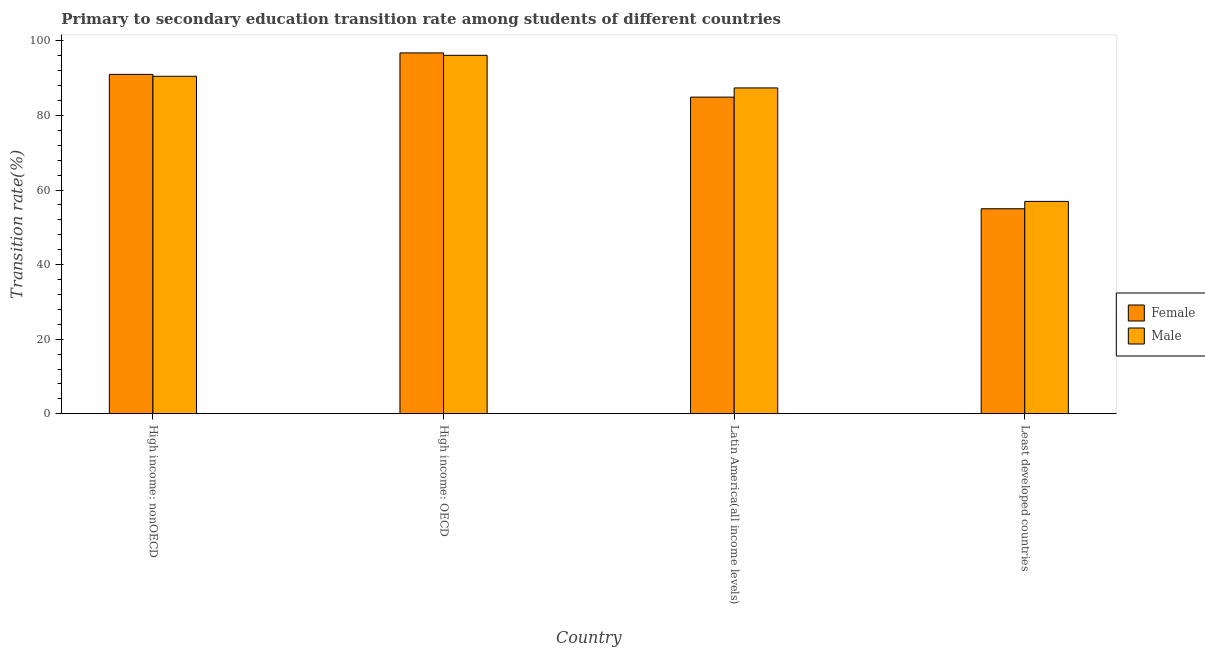Are the number of bars per tick equal to the number of legend labels?
Your answer should be compact. Yes. What is the label of the 2nd group of bars from the left?
Make the answer very short. High income: OECD. What is the transition rate among male students in Least developed countries?
Your response must be concise. 56.97. Across all countries, what is the maximum transition rate among male students?
Your answer should be very brief. 96.15. Across all countries, what is the minimum transition rate among female students?
Give a very brief answer. 54.99. In which country was the transition rate among male students maximum?
Your answer should be very brief. High income: OECD. In which country was the transition rate among male students minimum?
Keep it short and to the point. Least developed countries. What is the total transition rate among male students in the graph?
Provide a short and direct response. 331.06. What is the difference between the transition rate among female students in High income: nonOECD and that in Least developed countries?
Keep it short and to the point. 36.05. What is the difference between the transition rate among female students in Latin America(all income levels) and the transition rate among male students in High income: nonOECD?
Ensure brevity in your answer.  -5.59. What is the average transition rate among female students per country?
Give a very brief answer. 81.94. What is the difference between the transition rate among male students and transition rate among female students in Least developed countries?
Your response must be concise. 1.97. What is the ratio of the transition rate among female students in Latin America(all income levels) to that in Least developed countries?
Your answer should be very brief. 1.54. Is the transition rate among female students in High income: nonOECD less than that in Latin America(all income levels)?
Ensure brevity in your answer.  No. Is the difference between the transition rate among female students in High income: OECD and Least developed countries greater than the difference between the transition rate among male students in High income: OECD and Least developed countries?
Offer a terse response. Yes. What is the difference between the highest and the second highest transition rate among female students?
Ensure brevity in your answer.  5.75. What is the difference between the highest and the lowest transition rate among male students?
Keep it short and to the point. 39.19. How many bars are there?
Keep it short and to the point. 8. What is the difference between two consecutive major ticks on the Y-axis?
Provide a succinct answer. 20. Does the graph contain any zero values?
Make the answer very short. No. Does the graph contain grids?
Give a very brief answer. No. Where does the legend appear in the graph?
Provide a short and direct response. Center right. How many legend labels are there?
Provide a short and direct response. 2. What is the title of the graph?
Offer a terse response. Primary to secondary education transition rate among students of different countries. What is the label or title of the Y-axis?
Your response must be concise. Transition rate(%). What is the Transition rate(%) in Female in High income: nonOECD?
Make the answer very short. 91.05. What is the Transition rate(%) in Male in High income: nonOECD?
Your answer should be very brief. 90.53. What is the Transition rate(%) of Female in High income: OECD?
Offer a terse response. 96.8. What is the Transition rate(%) of Male in High income: OECD?
Your response must be concise. 96.15. What is the Transition rate(%) of Female in Latin America(all income levels)?
Offer a terse response. 84.94. What is the Transition rate(%) of Male in Latin America(all income levels)?
Your answer should be compact. 87.41. What is the Transition rate(%) in Female in Least developed countries?
Your answer should be compact. 54.99. What is the Transition rate(%) of Male in Least developed countries?
Offer a very short reply. 56.97. Across all countries, what is the maximum Transition rate(%) in Female?
Provide a short and direct response. 96.8. Across all countries, what is the maximum Transition rate(%) in Male?
Your response must be concise. 96.15. Across all countries, what is the minimum Transition rate(%) of Female?
Give a very brief answer. 54.99. Across all countries, what is the minimum Transition rate(%) in Male?
Ensure brevity in your answer.  56.97. What is the total Transition rate(%) in Female in the graph?
Ensure brevity in your answer.  327.78. What is the total Transition rate(%) in Male in the graph?
Give a very brief answer. 331.06. What is the difference between the Transition rate(%) of Female in High income: nonOECD and that in High income: OECD?
Your response must be concise. -5.75. What is the difference between the Transition rate(%) in Male in High income: nonOECD and that in High income: OECD?
Ensure brevity in your answer.  -5.62. What is the difference between the Transition rate(%) of Female in High income: nonOECD and that in Latin America(all income levels)?
Your response must be concise. 6.1. What is the difference between the Transition rate(%) in Male in High income: nonOECD and that in Latin America(all income levels)?
Keep it short and to the point. 3.12. What is the difference between the Transition rate(%) of Female in High income: nonOECD and that in Least developed countries?
Your answer should be compact. 36.05. What is the difference between the Transition rate(%) in Male in High income: nonOECD and that in Least developed countries?
Provide a short and direct response. 33.56. What is the difference between the Transition rate(%) of Female in High income: OECD and that in Latin America(all income levels)?
Give a very brief answer. 11.86. What is the difference between the Transition rate(%) in Male in High income: OECD and that in Latin America(all income levels)?
Give a very brief answer. 8.75. What is the difference between the Transition rate(%) in Female in High income: OECD and that in Least developed countries?
Your response must be concise. 41.81. What is the difference between the Transition rate(%) of Male in High income: OECD and that in Least developed countries?
Your answer should be compact. 39.19. What is the difference between the Transition rate(%) of Female in Latin America(all income levels) and that in Least developed countries?
Offer a very short reply. 29.95. What is the difference between the Transition rate(%) of Male in Latin America(all income levels) and that in Least developed countries?
Provide a short and direct response. 30.44. What is the difference between the Transition rate(%) in Female in High income: nonOECD and the Transition rate(%) in Male in High income: OECD?
Keep it short and to the point. -5.11. What is the difference between the Transition rate(%) in Female in High income: nonOECD and the Transition rate(%) in Male in Latin America(all income levels)?
Provide a short and direct response. 3.64. What is the difference between the Transition rate(%) of Female in High income: nonOECD and the Transition rate(%) of Male in Least developed countries?
Ensure brevity in your answer.  34.08. What is the difference between the Transition rate(%) in Female in High income: OECD and the Transition rate(%) in Male in Latin America(all income levels)?
Your answer should be very brief. 9.39. What is the difference between the Transition rate(%) of Female in High income: OECD and the Transition rate(%) of Male in Least developed countries?
Your answer should be very brief. 39.83. What is the difference between the Transition rate(%) of Female in Latin America(all income levels) and the Transition rate(%) of Male in Least developed countries?
Your answer should be compact. 27.98. What is the average Transition rate(%) of Female per country?
Your answer should be compact. 81.94. What is the average Transition rate(%) of Male per country?
Your answer should be very brief. 82.76. What is the difference between the Transition rate(%) in Female and Transition rate(%) in Male in High income: nonOECD?
Offer a terse response. 0.52. What is the difference between the Transition rate(%) of Female and Transition rate(%) of Male in High income: OECD?
Give a very brief answer. 0.65. What is the difference between the Transition rate(%) in Female and Transition rate(%) in Male in Latin America(all income levels)?
Your answer should be compact. -2.47. What is the difference between the Transition rate(%) of Female and Transition rate(%) of Male in Least developed countries?
Offer a terse response. -1.97. What is the ratio of the Transition rate(%) of Female in High income: nonOECD to that in High income: OECD?
Give a very brief answer. 0.94. What is the ratio of the Transition rate(%) in Male in High income: nonOECD to that in High income: OECD?
Give a very brief answer. 0.94. What is the ratio of the Transition rate(%) in Female in High income: nonOECD to that in Latin America(all income levels)?
Give a very brief answer. 1.07. What is the ratio of the Transition rate(%) of Male in High income: nonOECD to that in Latin America(all income levels)?
Your response must be concise. 1.04. What is the ratio of the Transition rate(%) in Female in High income: nonOECD to that in Least developed countries?
Your response must be concise. 1.66. What is the ratio of the Transition rate(%) of Male in High income: nonOECD to that in Least developed countries?
Keep it short and to the point. 1.59. What is the ratio of the Transition rate(%) in Female in High income: OECD to that in Latin America(all income levels)?
Your answer should be compact. 1.14. What is the ratio of the Transition rate(%) of Male in High income: OECD to that in Latin America(all income levels)?
Provide a short and direct response. 1.1. What is the ratio of the Transition rate(%) of Female in High income: OECD to that in Least developed countries?
Make the answer very short. 1.76. What is the ratio of the Transition rate(%) in Male in High income: OECD to that in Least developed countries?
Offer a very short reply. 1.69. What is the ratio of the Transition rate(%) in Female in Latin America(all income levels) to that in Least developed countries?
Ensure brevity in your answer.  1.54. What is the ratio of the Transition rate(%) in Male in Latin America(all income levels) to that in Least developed countries?
Ensure brevity in your answer.  1.53. What is the difference between the highest and the second highest Transition rate(%) in Female?
Offer a terse response. 5.75. What is the difference between the highest and the second highest Transition rate(%) of Male?
Ensure brevity in your answer.  5.62. What is the difference between the highest and the lowest Transition rate(%) in Female?
Your answer should be very brief. 41.81. What is the difference between the highest and the lowest Transition rate(%) of Male?
Your answer should be compact. 39.19. 